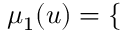<formula> <loc_0><loc_0><loc_500><loc_500>\begin{array} { r } { \mu _ { 1 } ( u ) = \left \{ \begin{array} { r l } \end{array} } \end{array}</formula> 